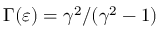<formula> <loc_0><loc_0><loc_500><loc_500>\Gamma ( \varepsilon ) = \gamma ^ { 2 } / ( \gamma ^ { 2 } - 1 )</formula> 